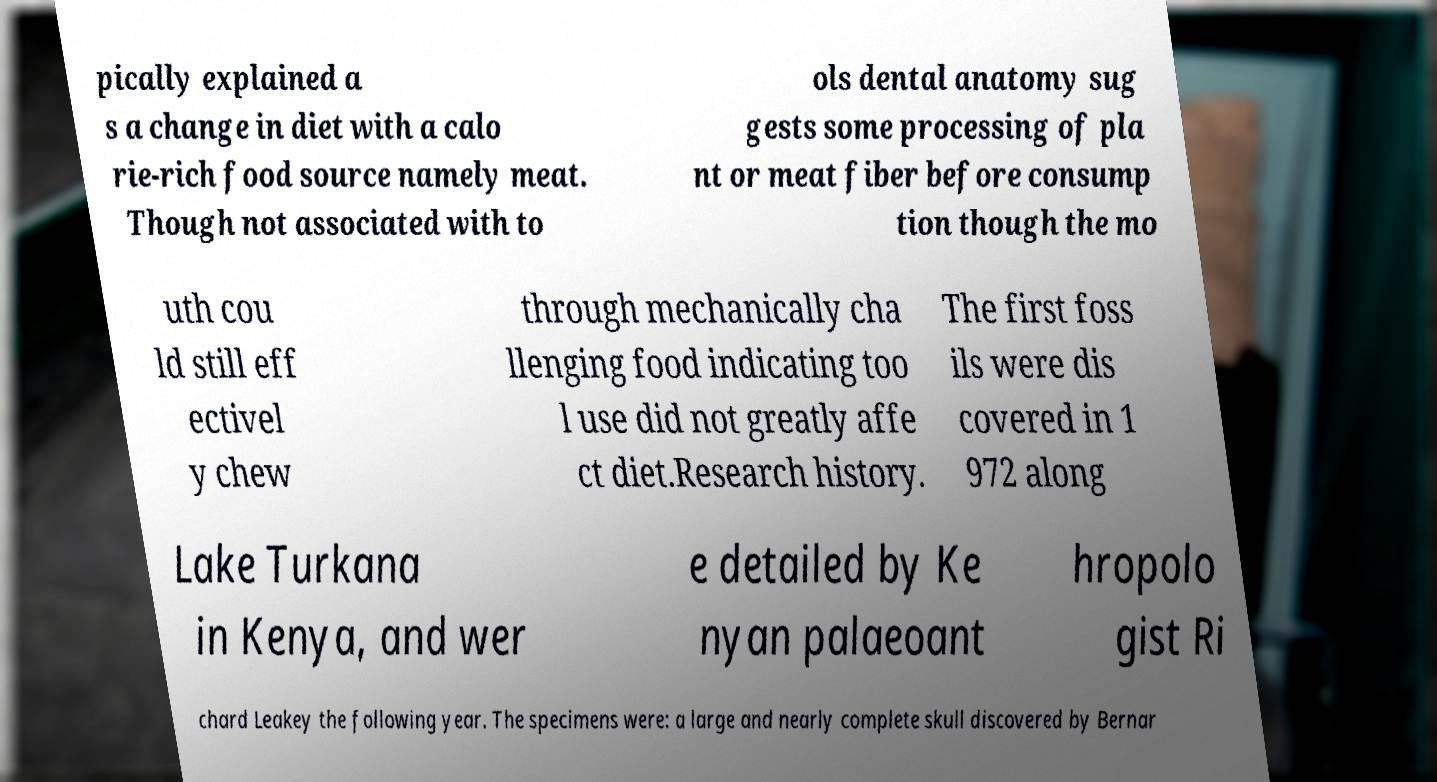There's text embedded in this image that I need extracted. Can you transcribe it verbatim? pically explained a s a change in diet with a calo rie-rich food source namely meat. Though not associated with to ols dental anatomy sug gests some processing of pla nt or meat fiber before consump tion though the mo uth cou ld still eff ectivel y chew through mechanically cha llenging food indicating too l use did not greatly affe ct diet.Research history. The first foss ils were dis covered in 1 972 along Lake Turkana in Kenya, and wer e detailed by Ke nyan palaeoant hropolo gist Ri chard Leakey the following year. The specimens were: a large and nearly complete skull discovered by Bernar 